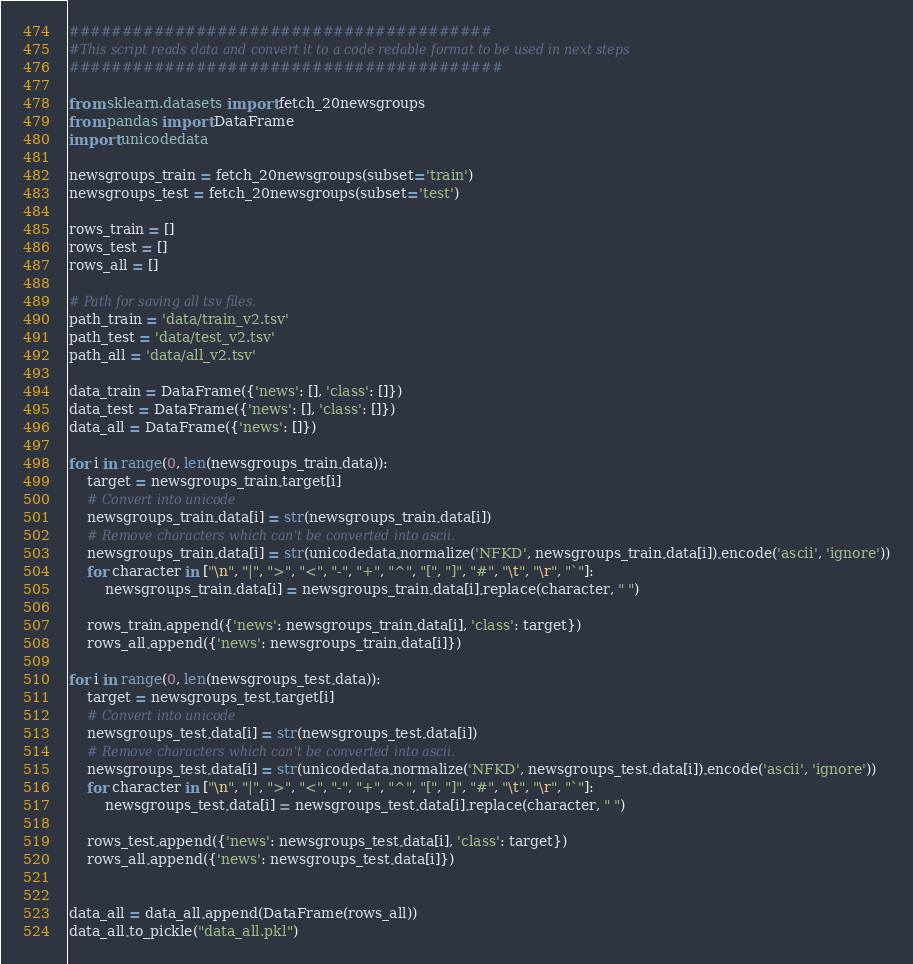Convert code to text. <code><loc_0><loc_0><loc_500><loc_500><_Python_>########################################
#This script reads data and convert it to a code redable format to be used in next steps
#########################################

from sklearn.datasets import fetch_20newsgroups
from pandas import DataFrame
import unicodedata

newsgroups_train = fetch_20newsgroups(subset='train')
newsgroups_test = fetch_20newsgroups(subset='test')

rows_train = []
rows_test = []
rows_all = []

# Path for saving all tsv files.
path_train = 'data/train_v2.tsv'
path_test = 'data/test_v2.tsv'
path_all = 'data/all_v2.tsv'

data_train = DataFrame({'news': [], 'class': []})
data_test = DataFrame({'news': [], 'class': []})
data_all = DataFrame({'news': []})

for i in range(0, len(newsgroups_train.data)):
    target = newsgroups_train.target[i]
    # Convert into unicode
    newsgroups_train.data[i] = str(newsgroups_train.data[i])
    # Remove characters which can't be converted into ascii.
    newsgroups_train.data[i] = str(unicodedata.normalize('NFKD', newsgroups_train.data[i]).encode('ascii', 'ignore'))
    for character in ["\n", "|", ">", "<", "-", "+", "^", "[", "]", "#", "\t", "\r", "`"]:
        newsgroups_train.data[i] = newsgroups_train.data[i].replace(character, " ")

    rows_train.append({'news': newsgroups_train.data[i], 'class': target})
    rows_all.append({'news': newsgroups_train.data[i]})

for i in range(0, len(newsgroups_test.data)):
    target = newsgroups_test.target[i]
    # Convert into unicode
    newsgroups_test.data[i] = str(newsgroups_test.data[i])
    # Remove characters which can't be converted into ascii.
    newsgroups_test.data[i] = str(unicodedata.normalize('NFKD', newsgroups_test.data[i]).encode('ascii', 'ignore'))
    for character in ["\n", "|", ">", "<", "-", "+", "^", "[", "]", "#", "\t", "\r", "`"]:
        newsgroups_test.data[i] = newsgroups_test.data[i].replace(character, " ")

    rows_test.append({'news': newsgroups_test.data[i], 'class': target})
    rows_all.append({'news': newsgroups_test.data[i]})


data_all = data_all.append(DataFrame(rows_all))
data_all.to_pickle("data_all.pkl")
</code> 